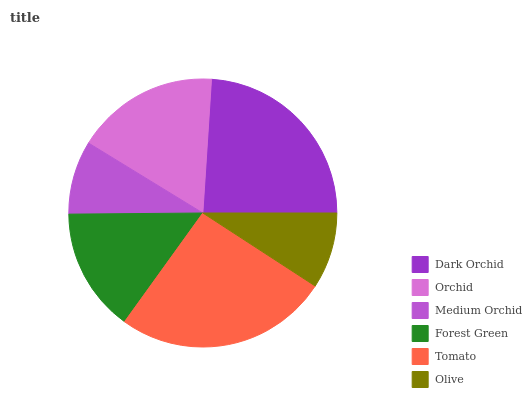Is Medium Orchid the minimum?
Answer yes or no. Yes. Is Tomato the maximum?
Answer yes or no. Yes. Is Orchid the minimum?
Answer yes or no. No. Is Orchid the maximum?
Answer yes or no. No. Is Dark Orchid greater than Orchid?
Answer yes or no. Yes. Is Orchid less than Dark Orchid?
Answer yes or no. Yes. Is Orchid greater than Dark Orchid?
Answer yes or no. No. Is Dark Orchid less than Orchid?
Answer yes or no. No. Is Orchid the high median?
Answer yes or no. Yes. Is Forest Green the low median?
Answer yes or no. Yes. Is Dark Orchid the high median?
Answer yes or no. No. Is Tomato the low median?
Answer yes or no. No. 